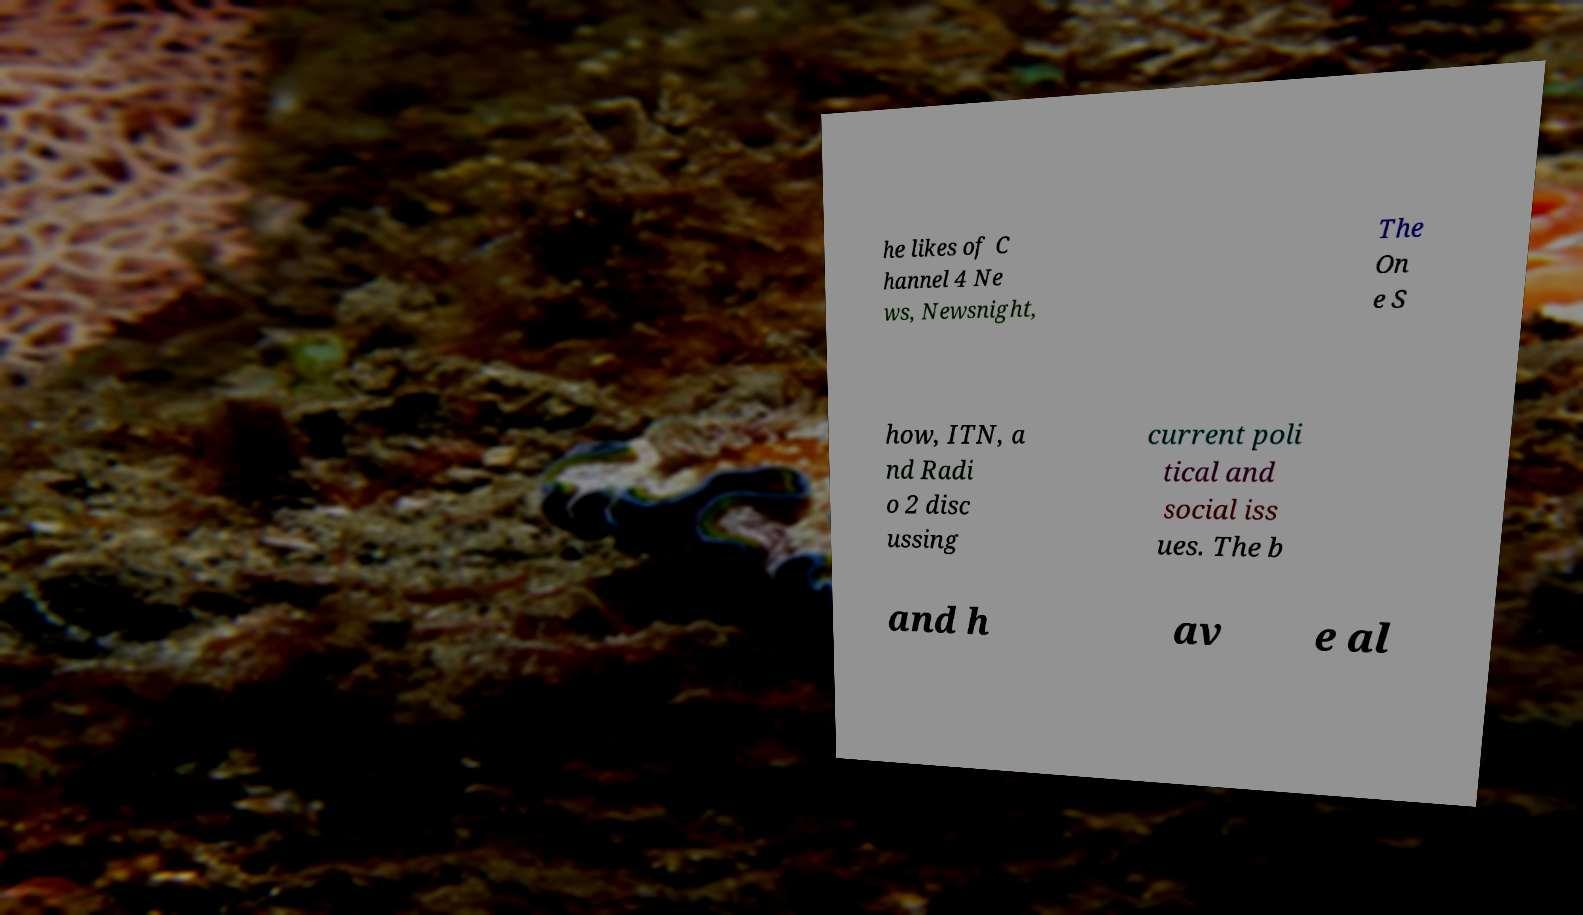There's text embedded in this image that I need extracted. Can you transcribe it verbatim? he likes of C hannel 4 Ne ws, Newsnight, The On e S how, ITN, a nd Radi o 2 disc ussing current poli tical and social iss ues. The b and h av e al 